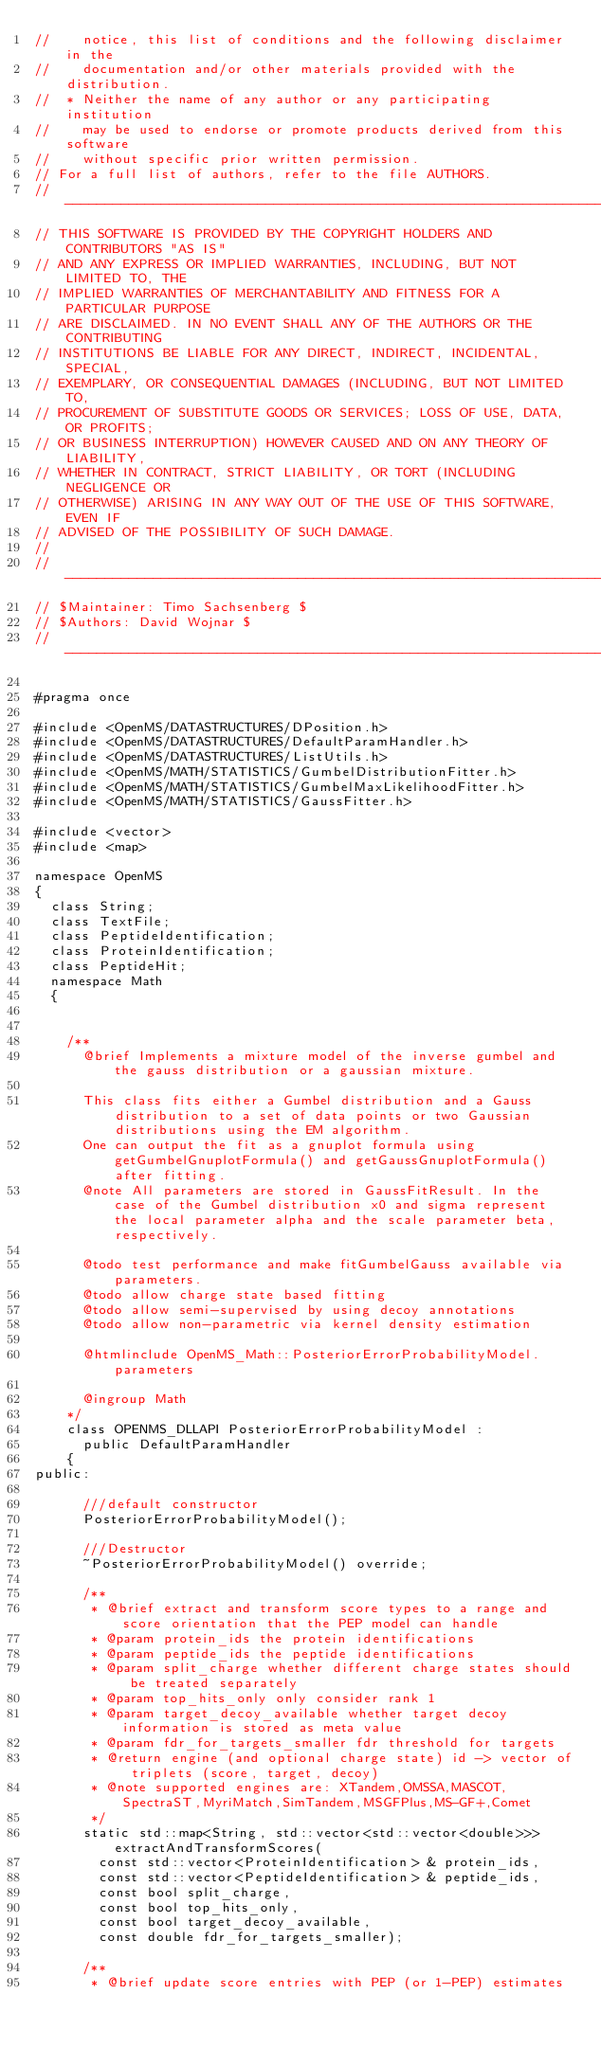Convert code to text. <code><loc_0><loc_0><loc_500><loc_500><_C_>//    notice, this list of conditions and the following disclaimer in the
//    documentation and/or other materials provided with the distribution.
//  * Neither the name of any author or any participating institution
//    may be used to endorse or promote products derived from this software
//    without specific prior written permission.
// For a full list of authors, refer to the file AUTHORS.
// --------------------------------------------------------------------------
// THIS SOFTWARE IS PROVIDED BY THE COPYRIGHT HOLDERS AND CONTRIBUTORS "AS IS"
// AND ANY EXPRESS OR IMPLIED WARRANTIES, INCLUDING, BUT NOT LIMITED TO, THE
// IMPLIED WARRANTIES OF MERCHANTABILITY AND FITNESS FOR A PARTICULAR PURPOSE
// ARE DISCLAIMED. IN NO EVENT SHALL ANY OF THE AUTHORS OR THE CONTRIBUTING
// INSTITUTIONS BE LIABLE FOR ANY DIRECT, INDIRECT, INCIDENTAL, SPECIAL,
// EXEMPLARY, OR CONSEQUENTIAL DAMAGES (INCLUDING, BUT NOT LIMITED TO,
// PROCUREMENT OF SUBSTITUTE GOODS OR SERVICES; LOSS OF USE, DATA, OR PROFITS;
// OR BUSINESS INTERRUPTION) HOWEVER CAUSED AND ON ANY THEORY OF LIABILITY,
// WHETHER IN CONTRACT, STRICT LIABILITY, OR TORT (INCLUDING NEGLIGENCE OR
// OTHERWISE) ARISING IN ANY WAY OUT OF THE USE OF THIS SOFTWARE, EVEN IF
// ADVISED OF THE POSSIBILITY OF SUCH DAMAGE.
//
// --------------------------------------------------------------------------
// $Maintainer: Timo Sachsenberg $
// $Authors: David Wojnar $
// --------------------------------------------------------------------------

#pragma once

#include <OpenMS/DATASTRUCTURES/DPosition.h>
#include <OpenMS/DATASTRUCTURES/DefaultParamHandler.h>
#include <OpenMS/DATASTRUCTURES/ListUtils.h>
#include <OpenMS/MATH/STATISTICS/GumbelDistributionFitter.h>
#include <OpenMS/MATH/STATISTICS/GumbelMaxLikelihoodFitter.h>
#include <OpenMS/MATH/STATISTICS/GaussFitter.h>

#include <vector>
#include <map>

namespace OpenMS
{
  class String;
  class TextFile;
  class PeptideIdentification;
  class ProteinIdentification;
  class PeptideHit;
  namespace Math
  {


    /**
      @brief Implements a mixture model of the inverse gumbel and the gauss distribution or a gaussian mixture.

      This class fits either a Gumbel distribution and a Gauss distribution to a set of data points or two Gaussian distributions using the EM algorithm.
      One can output the fit as a gnuplot formula using getGumbelGnuplotFormula() and getGaussGnuplotFormula() after fitting.
      @note All parameters are stored in GaussFitResult. In the case of the Gumbel distribution x0 and sigma represent the local parameter alpha and the scale parameter beta, respectively.

      @todo test performance and make fitGumbelGauss available via parameters.
      @todo allow charge state based fitting
      @todo allow semi-supervised by using decoy annotations
      @todo allow non-parametric via kernel density estimation

      @htmlinclude OpenMS_Math::PosteriorErrorProbabilityModel.parameters

      @ingroup Math
    */
    class OPENMS_DLLAPI PosteriorErrorProbabilityModel :
      public DefaultParamHandler
    {
public:

      ///default constructor
      PosteriorErrorProbabilityModel();

      ///Destructor
      ~PosteriorErrorProbabilityModel() override;

      /**
       * @brief extract and transform score types to a range and score orientation that the PEP model can handle
       * @param protein_ids the protein identifications
       * @param peptide_ids the peptide identifications
       * @param split_charge whether different charge states should be treated separately
       * @param top_hits_only only consider rank 1
       * @param target_decoy_available whether target decoy information is stored as meta value
       * @param fdr_for_targets_smaller fdr threshold for targets
       * @return engine (and optional charge state) id -> vector of triplets (score, target, decoy)
       * @note supported engines are: XTandem,OMSSA,MASCOT,SpectraST,MyriMatch,SimTandem,MSGFPlus,MS-GF+,Comet
       */
      static std::map<String, std::vector<std::vector<double>>> extractAndTransformScores(
        const std::vector<ProteinIdentification> & protein_ids,
        const std::vector<PeptideIdentification> & peptide_ids,
        const bool split_charge,
        const bool top_hits_only,
        const bool target_decoy_available,
        const double fdr_for_targets_smaller);

      /**
       * @brief update score entries with PEP (or 1-PEP) estimates</code> 